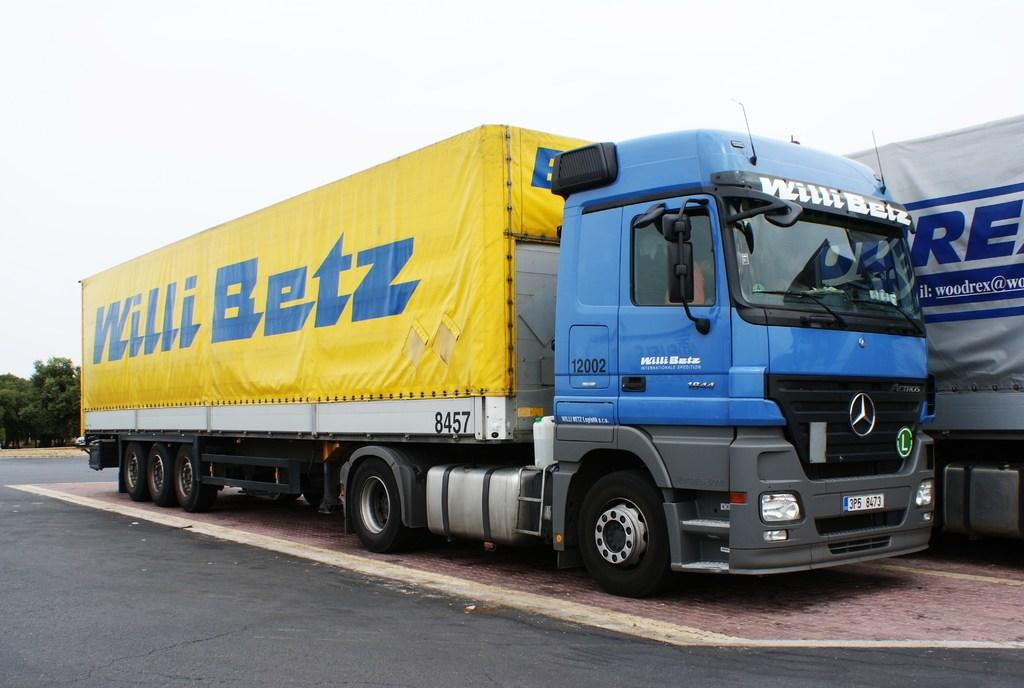What type of vehicles can be seen on the road in the image? There are trucks on the road in the image. What can be seen in the distance behind the trucks? There are trees visible in the background of the image. How many fingers can be seen on the son of the laborer in the image? There is no son or laborer present in the image; it only features trucks on the road and trees in the background. 